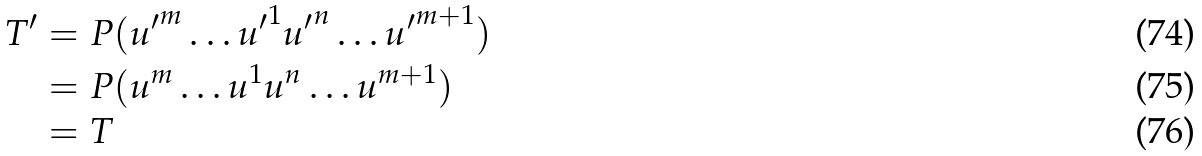Convert formula to latex. <formula><loc_0><loc_0><loc_500><loc_500>T ^ { \prime } & = P ( { u ^ { \prime } } ^ { m } \dots { u ^ { \prime } } ^ { 1 } { u ^ { \prime } } ^ { n } \dots { u ^ { \prime } } ^ { m + 1 } ) \\ & = P ( u ^ { m } \dots u ^ { 1 } u ^ { n } \dots u ^ { m + 1 } ) \\ & = T</formula> 